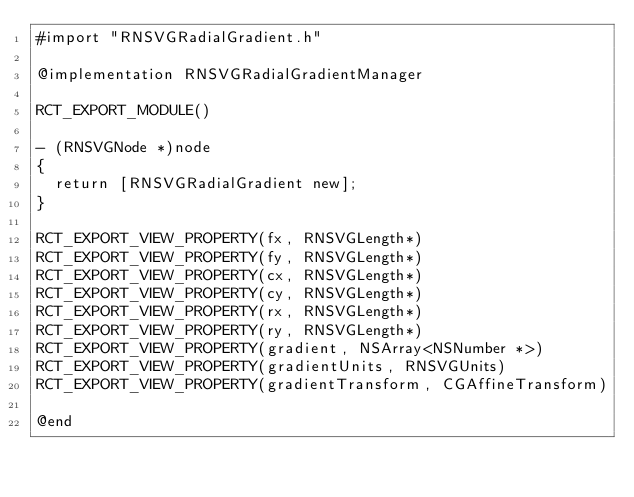Convert code to text. <code><loc_0><loc_0><loc_500><loc_500><_ObjectiveC_>#import "RNSVGRadialGradient.h"

@implementation RNSVGRadialGradientManager

RCT_EXPORT_MODULE()

- (RNSVGNode *)node
{
  return [RNSVGRadialGradient new];
}

RCT_EXPORT_VIEW_PROPERTY(fx, RNSVGLength*)
RCT_EXPORT_VIEW_PROPERTY(fy, RNSVGLength*)
RCT_EXPORT_VIEW_PROPERTY(cx, RNSVGLength*)
RCT_EXPORT_VIEW_PROPERTY(cy, RNSVGLength*)
RCT_EXPORT_VIEW_PROPERTY(rx, RNSVGLength*)
RCT_EXPORT_VIEW_PROPERTY(ry, RNSVGLength*)
RCT_EXPORT_VIEW_PROPERTY(gradient, NSArray<NSNumber *>)
RCT_EXPORT_VIEW_PROPERTY(gradientUnits, RNSVGUnits)
RCT_EXPORT_VIEW_PROPERTY(gradientTransform, CGAffineTransform)

@end
</code> 